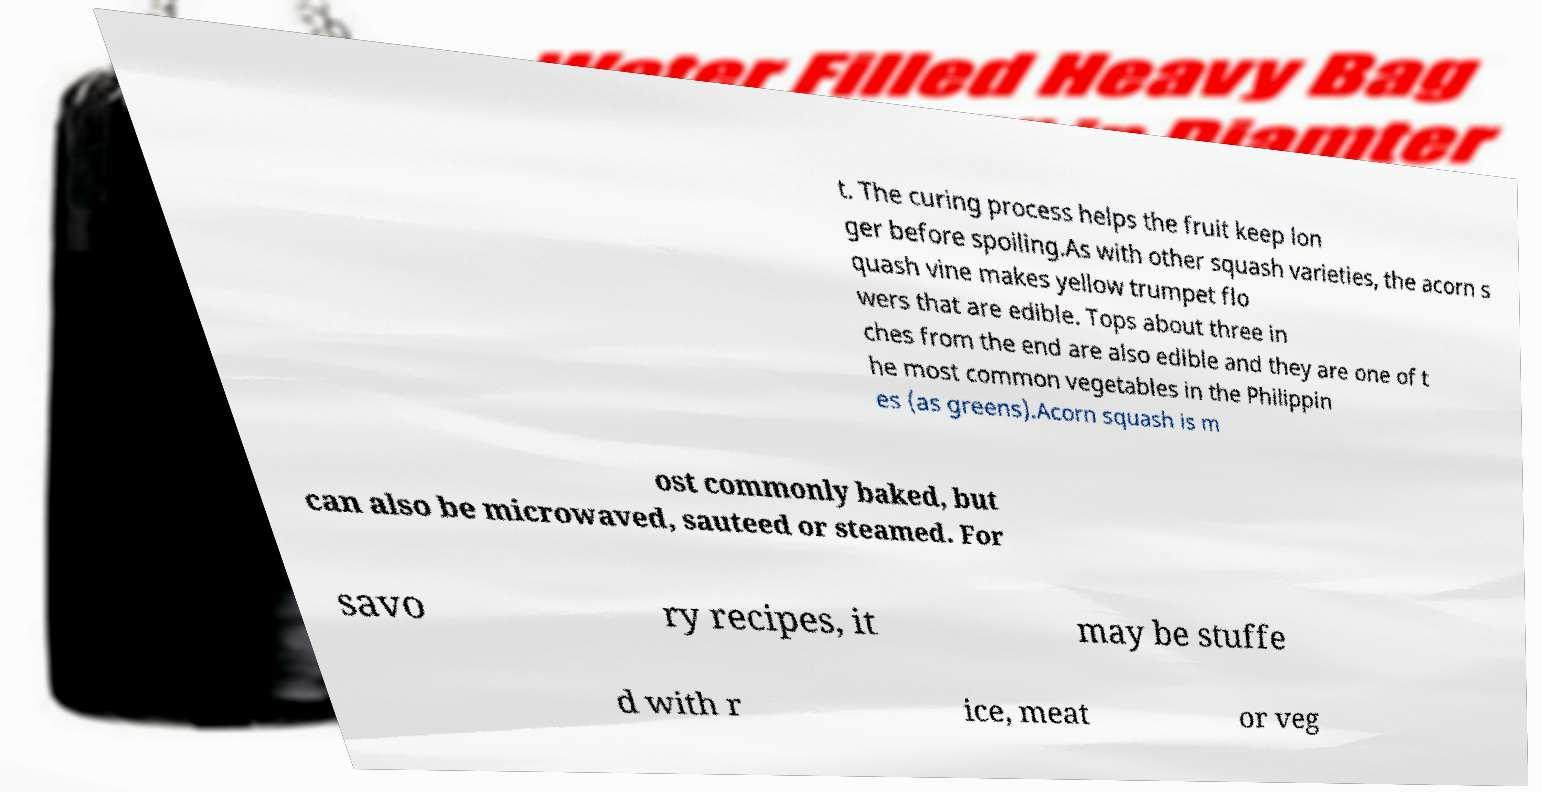Could you assist in decoding the text presented in this image and type it out clearly? t. The curing process helps the fruit keep lon ger before spoiling.As with other squash varieties, the acorn s quash vine makes yellow trumpet flo wers that are edible. Tops about three in ches from the end are also edible and they are one of t he most common vegetables in the Philippin es (as greens).Acorn squash is m ost commonly baked, but can also be microwaved, sauteed or steamed. For savo ry recipes, it may be stuffe d with r ice, meat or veg 